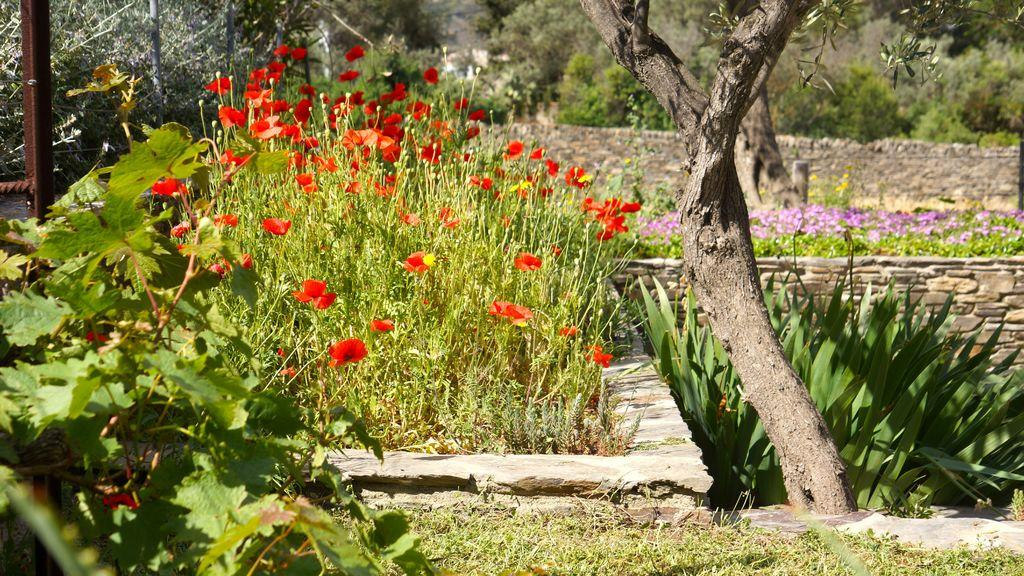What type of plants are in the foreground of the image? There are flower plants in the foreground of the image. What else can be seen in the image besides the flower plants? There is greenery in the image. What is visible in the background of the image? There appears to be a wall in the background of the image. Who is the creator of the mask seen in the image? There is no mask present in the image, so it is not possible to determine who created it. 